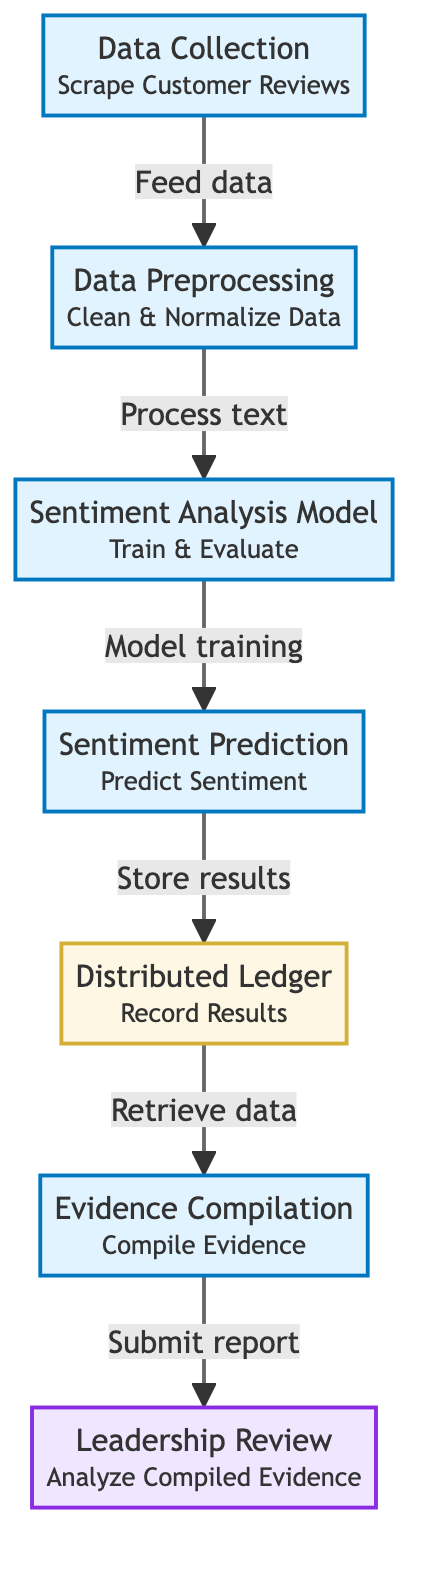What's the first process in the diagram? The first process is labeled 'Data Collection' which indicates that the initial step involves gathering customer reviews. This is the starting node in the flow of the diagram.
Answer: Data Collection How many processes are shown in the diagram? The diagram illustrates a total of five processes, which include Data Collection, Preprocessing, Sentiment Analysis Model, Prediction, and Evidence Compilation. Counting these gives a total of five.
Answer: Five What does the Distributed Ledger store? The Distributed Ledger records the results of the sentiment prediction made by the model. This is described directly within the corresponding node in the diagram.
Answer: Results What is the relationship between Prediction and Distributed Ledger? The relationship is that Prediction feeds its output (the predicted sentiments) to the Distributed Ledger, which stores the results for further use. This is described by the directed flow from Prediction to Distributed Ledger.
Answer: Store results Which node is tasked with analyzing the compiled evidence? The node responsible for analyzing the compiled evidence is labeled 'Leadership Review'. This is explicitly stated within that node, making it clear what its function is within the process.
Answer: Leadership Review What step comes directly after Data Preprocessing? The step that comes directly after Data Preprocessing is the Sentiment Analysis Model, indicating that once the data is cleaned and normalized, it then enters the model for training and evaluation.
Answer: Sentiment Analysis Model What is one of the outputs of the Sentiment Analysis Model? One of the outputs is 'Sentiment Prediction', which represents the predictions made by the model after its training phase. This output is a direct continuation from the model node.
Answer: Sentiment Prediction What is the final step in the process? The final step is 'Leadership Review', indicating that after evidence compilation, the leadership will analyze the compiled evidence as the last action in this workflow.
Answer: Leadership Review What is compiled in the Evidence Compilation step? The step is responsible for compiling the evidence collected from the Distributed Ledger, summarizing the sentiment results for further analysis. This information is explicitly mentioned in the node's description.
Answer: Evidence 